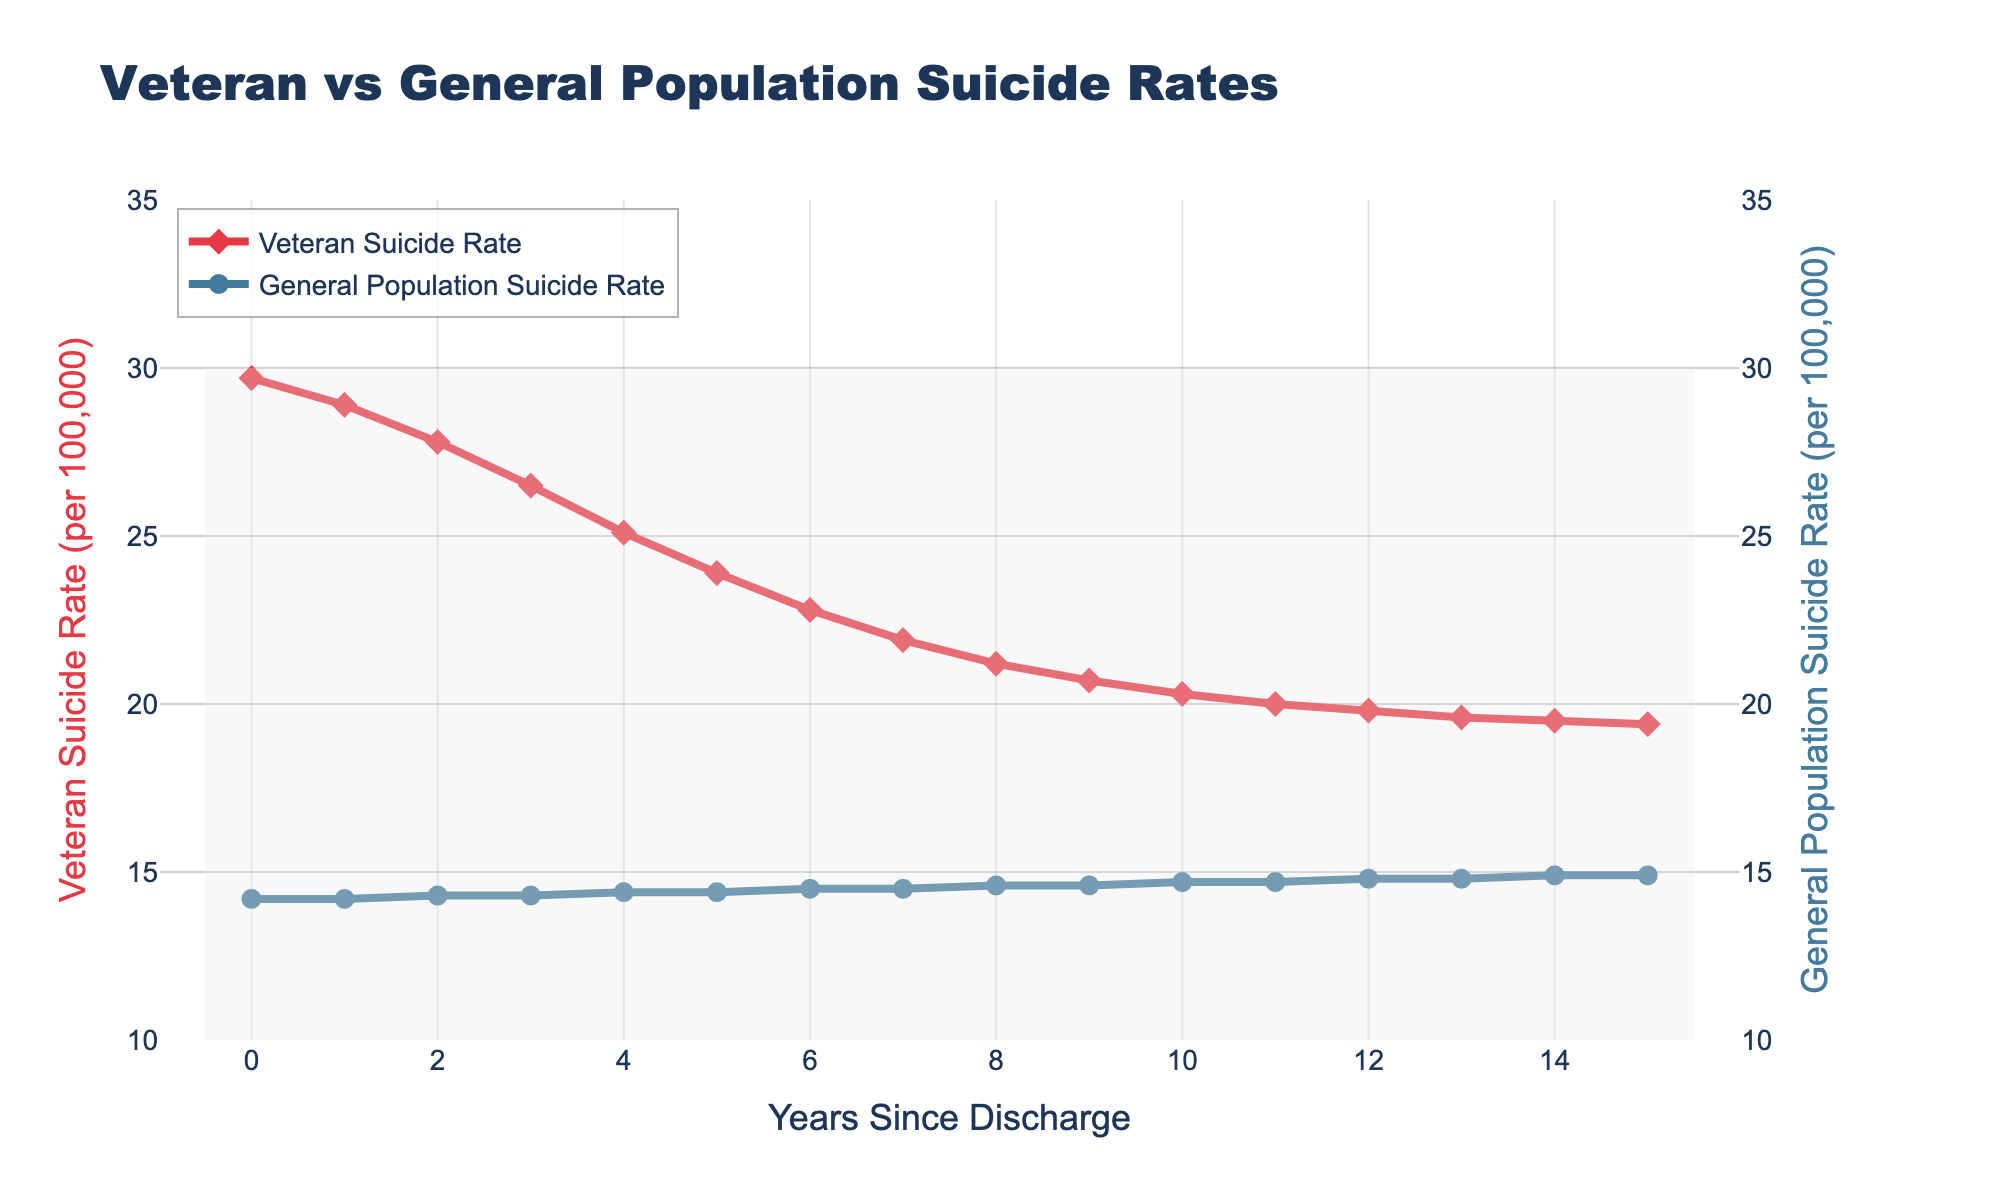Which group has the higher suicide rate at Year 5 since discharge? Look at Year 5 on the x-axis and compare the heights and values of the lines for Veteran Suicide Rate and General Population Suicide Rate. The Veteran Suicide Rate is 23.9 while the General Population Suicide Rate is 14.4.
Answer: Veterans How does the Veteran Suicide Rate change from Year 0 to Year 10 since discharge? Observe the Veteran Suicide Rate values at Year 0 (29.7) and Year 10 (20.3). Calculate the difference: 29.7 - 20.3 = 9.4. It decreases by 9.4 per 100,000.
Answer: Decreases by 9.4 What is the average General Population Suicide Rate over the 15-year period? Sum the General Population Suicide Rate values from Year 0 to Year 15 and divide by the number of years (16). Sum = 14.2 + 14.2 + 14.3 + 14.3 + 14.4 + 14.4 + 14.5 + 14.5 + 14.6 + 14.6 + 14.7 + 14.7 + 14.8 + 14.8 + 14.9 + 14.9 = 231.3. Average = 231.3 / 16 = 14.45625.
Answer: 14.5 At what year does the Veteran Suicide Rate first become less than 25 per 100,000? Move along the Veteran Suicide Rate line to find where it first drops below 25. This occurs at Year 5 (23.9).
Answer: Year 5 How much does the General Population Suicide Rate increase from Year 0 to Year 15? Compare the General Population Suicide Rate at Year 0 (14.2) and Year 15 (14.9). Calculate the difference: 14.9 - 14.2 = 0.7. It increases by 0.7 per 100,000.
Answer: 0.7 What is the difference in Suicide Rates between Veterans and the General Population at Year 10 since discharge? Look at Year 10 on the x-axis and find the values: Veteran Suicide Rate = 20.3, General Population Suicide Rate = 14.7. Calculate the difference: 20.3 - 14.7 = 5.6.
Answer: 5.6 Which has a steeper decline over time, the Veteran Suicide Rate or the General Population Suicide Rate from Year 0 to Year 15? Compare the overall slopes of both lines over the 15-year period. The Veteran Suicide Rate decreases from 29.7 to 19.4 (10.3 units), while the General Population Suicide Rate increases slightly from 14.2 to 14.9 (0.7 units). The Veteran rate shows a steep decline.
Answer: Veteran Suicide Rate What is the cumulative reduction in Veteran Suicide Rate from Year 0 to Year 15? Observe the Veteran Suicide Rate values at Year 0 (29.7) and at Year 15 (19.4). The reduction is 29.7 - 19.4 = 10.3 per 100,000.
Answer: 10.3 At which year do the rates show the smallest difference between Veterans and the General Population? Track the difference between the lines at all points and find the smallest value. At Year 15, Veteran Suicide Rate is 19.4 and General Population Suicide Rate is 14.9, the difference is 19.4 - 14.9 = 4.5, which is smaller than any other year.
Answer: Year 15 